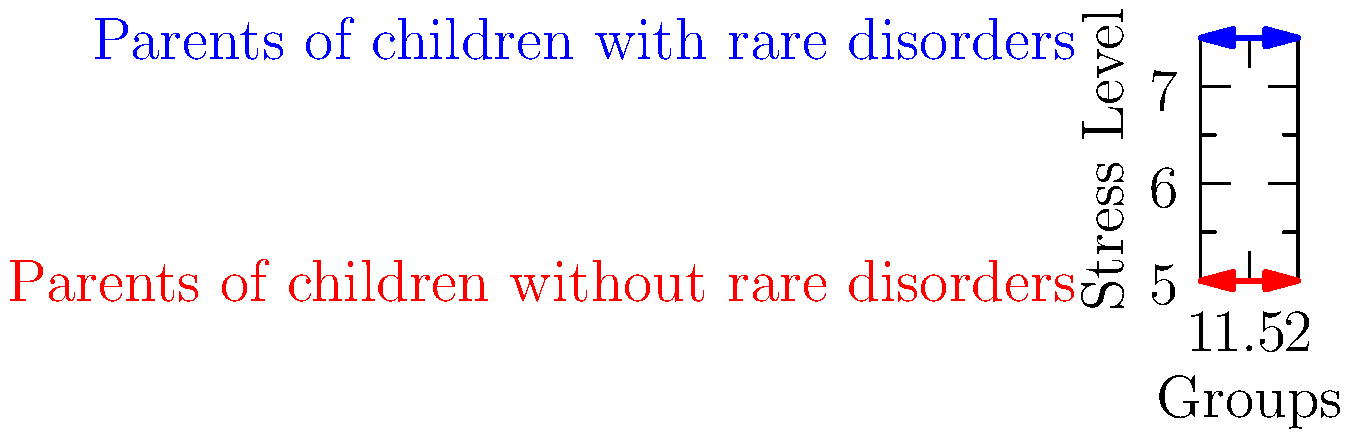Based on the graph, what is the approximate difference in stress levels between parents of children with rare disorders and those without? To find the difference in stress levels:

1. Identify stress level for parents of children with rare disorders: $7.5$
2. Identify stress level for parents of children without rare disorders: $5$
3. Calculate the difference: $7.5 - 5 = 2.5$

The graph shows a constant stress level for each group across the x-axis, indicating a consistent difference between the two groups.
Answer: $2.5$ 